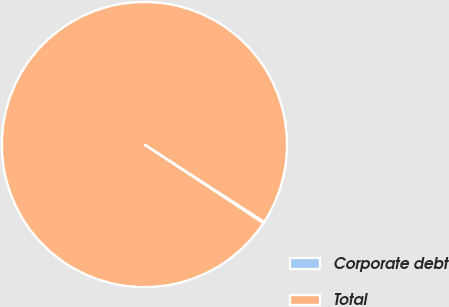<chart> <loc_0><loc_0><loc_500><loc_500><pie_chart><fcel>Corporate debt<fcel>Total<nl><fcel>0.17%<fcel>99.83%<nl></chart> 